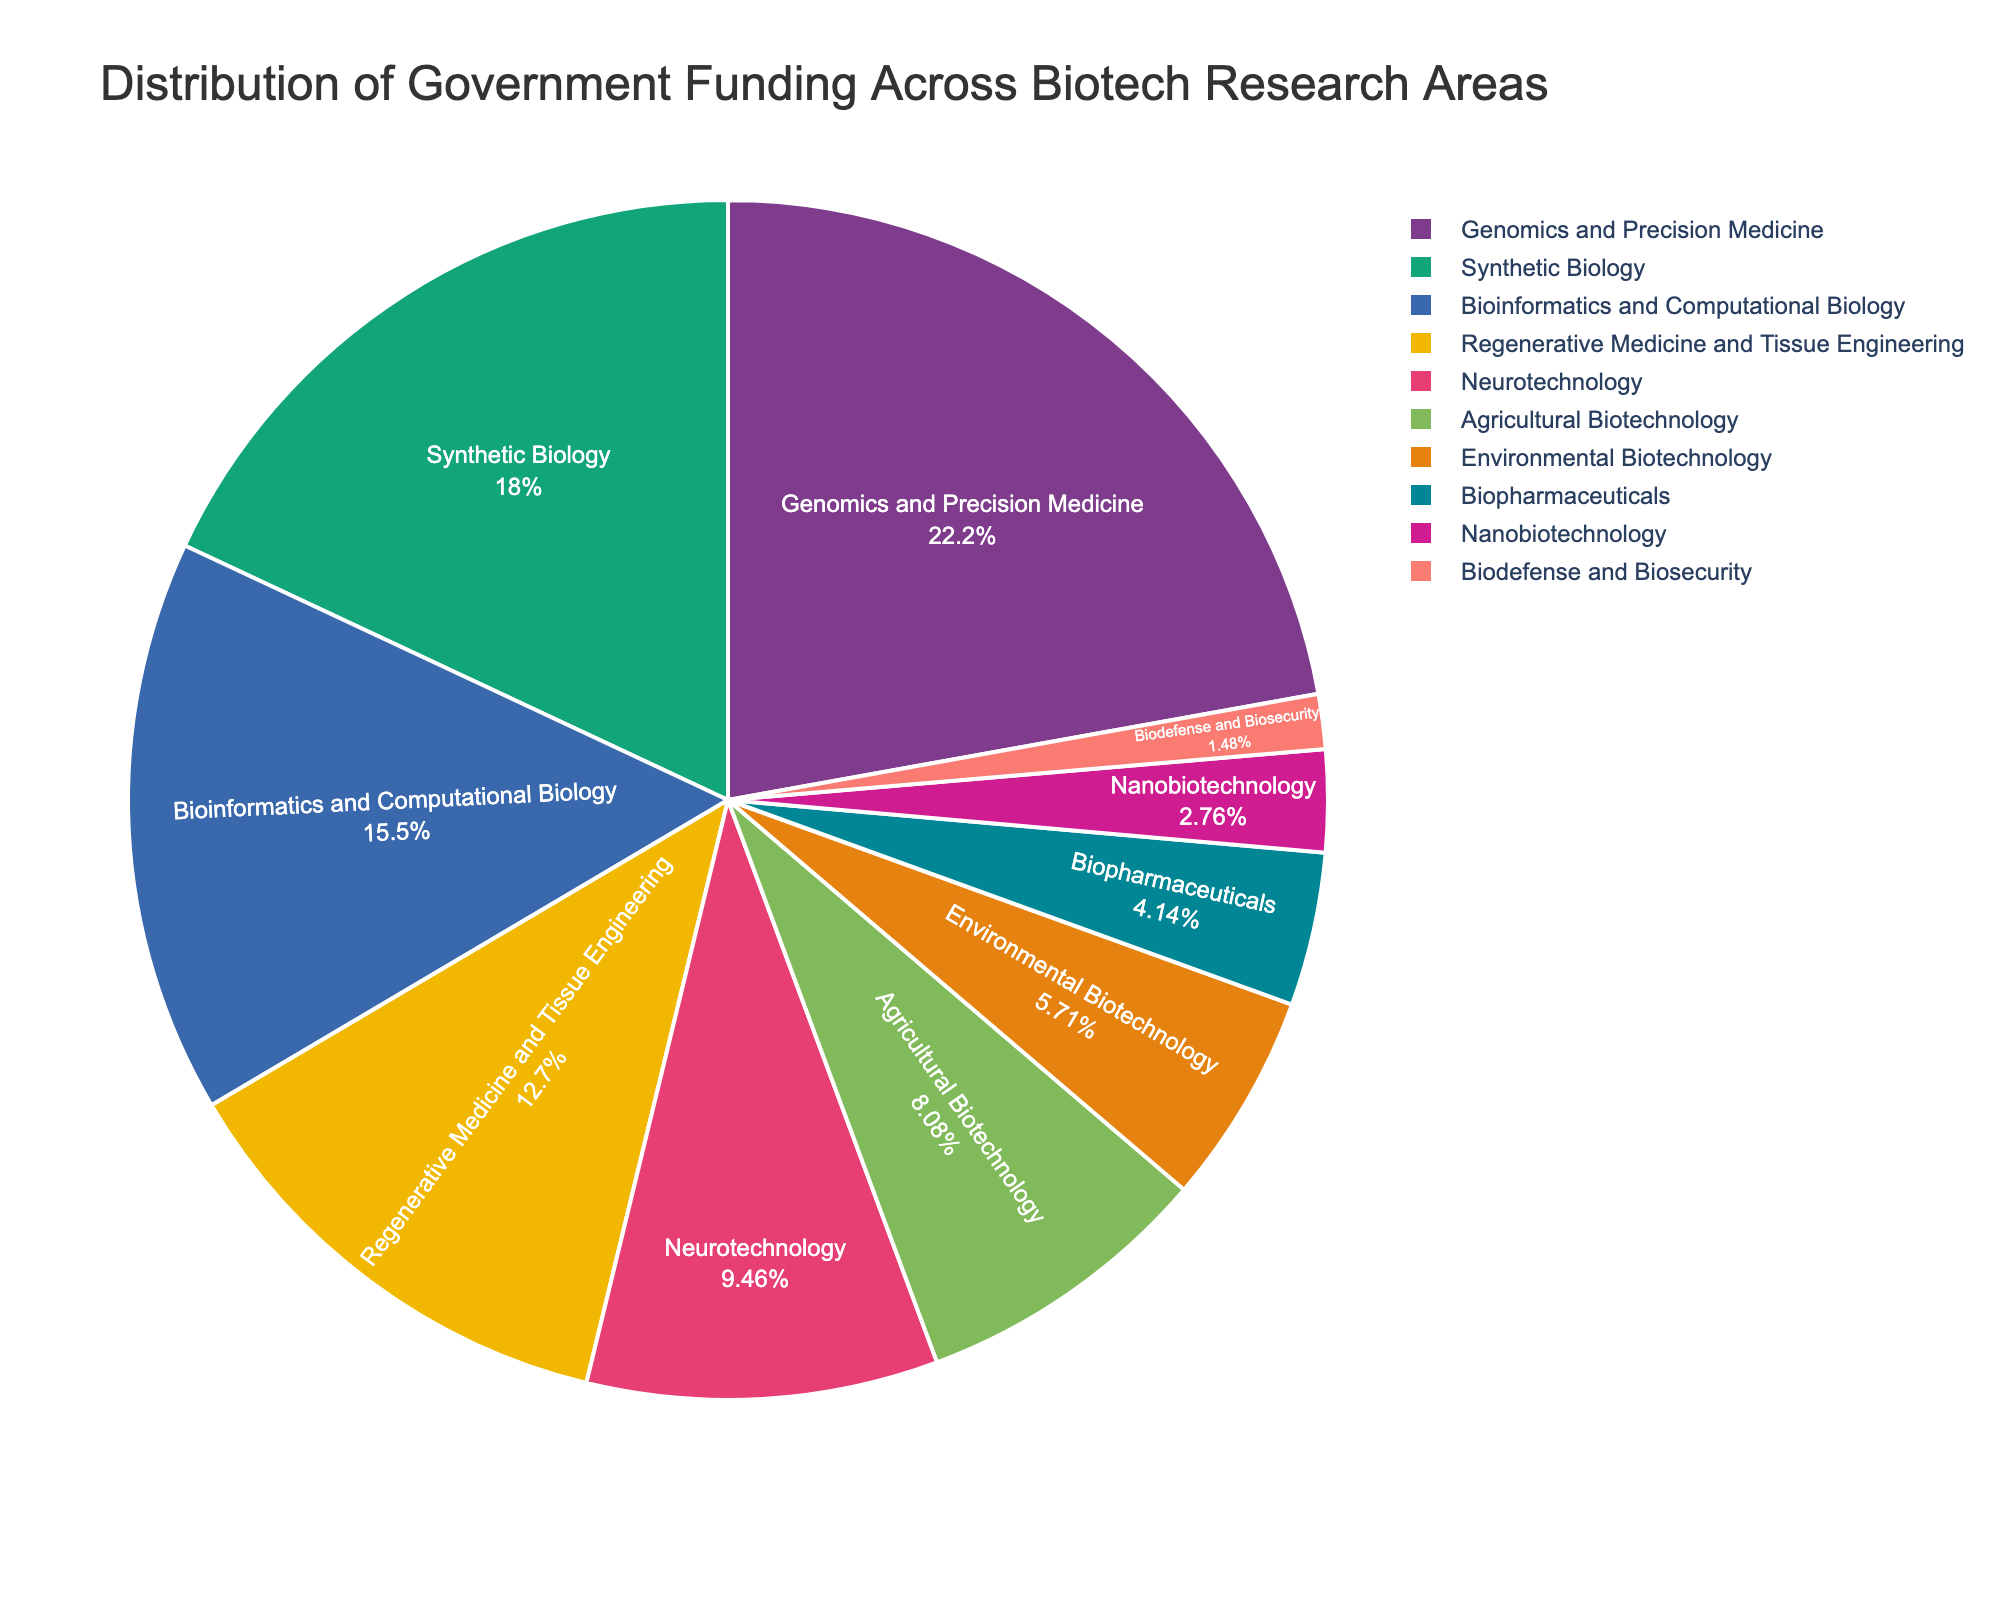Which research area receives the highest percentage of funding? The figure shows that "Genomics and Precision Medicine" receives the highest funding with a percentage label of 22.5%.
Answer: Genomics and Precision Medicine What is the combined funding percentage for "Synthetic Biology" and "Bioinformatics and Computational Biology"? The funding percentages for "Synthetic Biology" and "Bioinformatics and Computational Biology" are 18.3% and 15.7% respectively. Adding these gives 18.3% + 15.7% = 34.0%.
Answer: 34.0% Which three research areas receive the least funding? The three lowest funding areas based on the pie chart are "Biodefense and Biosecurity" (1.5%), "Nanobiotechnology" (2.8%), and "Biopharmaceuticals" (4.2%).
Answer: Biodefense and Biosecurity, Nanobiotechnology, Biopharmaceuticals Is funding for "Neurotechnology" greater or less than "Regenerative Medicine and Tissue Engineering"? The figure shows "Neurotechnology" with 9.6% and "Regenerative Medicine and Tissue Engineering" with 12.9%. Comparing these values, 9.6% is less than 12.9%.
Answer: Less What is the difference in funding percentages between "Environmental Biotechnology" and "Agricultural Biotechnology"? The funding percentages are 5.8% for "Environmental Biotechnology" and 8.2% for "Agricultural Biotechnology". The difference is 8.2% - 5.8% = 2.4%.
Answer: 2.4% Which research area has a funding percentage closest to 10%? The funding percentages are provided on the pie chart. "Neurotechnology" has a percentage of 9.6%, which is closest to 10%.
Answer: Neurotechnology What is the combined funding percentage for the areas: "Bioinformatics and Computational Biology", "Regenerative Medicine and Tissue Engineering", and "Neurotechnology"? The funding percentages for these areas are 15.7%, 12.9%, and 9.6% respectively. The combined funding percentage is 15.7% + 12.9% + 9.6% = 38.2%.
Answer: 38.2% Do "Bioinformatics and Computational Biology" and "Environmental Biotechnology" together receive more funding than "Synthetic Biology"? The combined funding for "Bioinformatics and Computational Biology" (15.7%) and "Environmental Biotechnology" (5.8%) is 15.7% + 5.8% = 21.5%, which is greater than the funding for "Synthetic Biology" (18.3%).
Answer: Yes Which research area has a darker color in the pie chart: "Genomics and Precision Medicine" or "Biopharmaceuticals"? Based on the custom color palette used in the plot, "Genomics and Precision Medicine" generally corresponds to a darker color in the qualitative Bold palette, while "Biopharmaceuticals" corresponds to a lighter color in the qualitative Pastel palette.
Answer: Genomics and Precision Medicine 